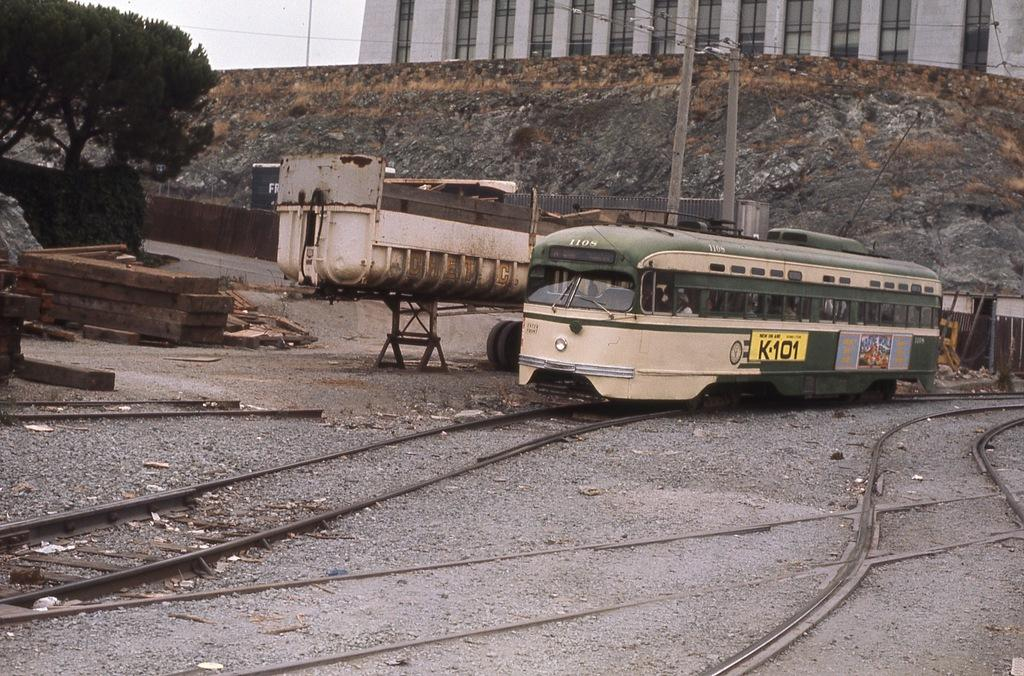Provide a one-sentence caption for the provided image. A disused railway yard with an old green and cream tramcar with the number 1108. 